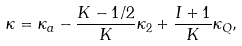<formula> <loc_0><loc_0><loc_500><loc_500>\kappa = \kappa _ { a } - \frac { K - 1 / 2 } { K } \kappa _ { 2 } + \frac { I + 1 } { K } \kappa _ { Q } ,</formula> 